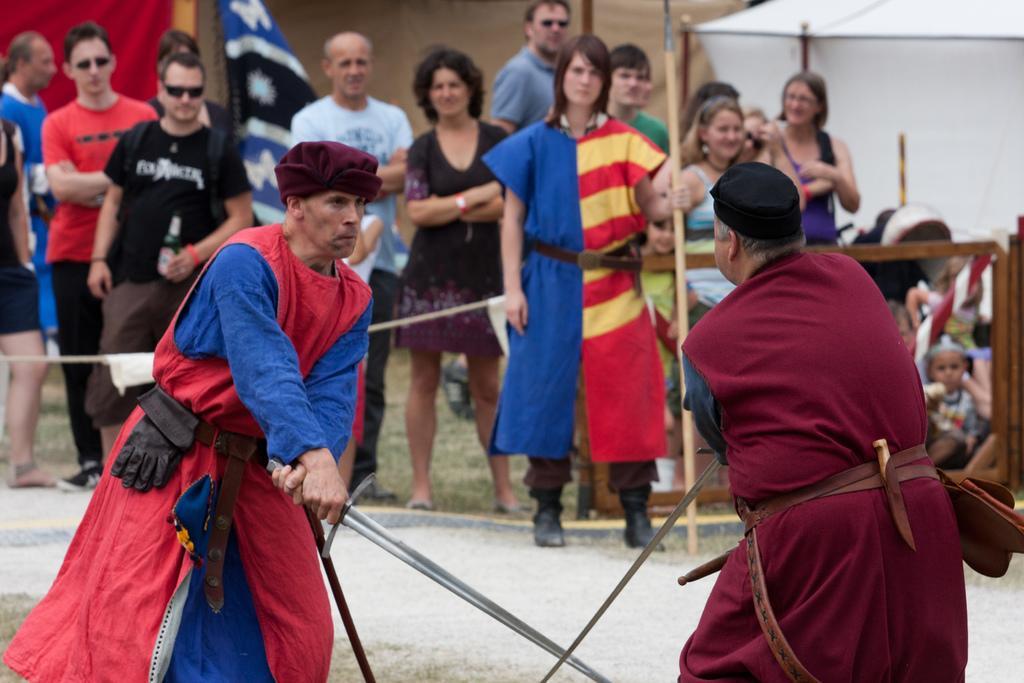In one or two sentences, can you explain what this image depicts? In this picture we can see two persons are fighting with sword, around few people are standing and watching and we can see flags. 